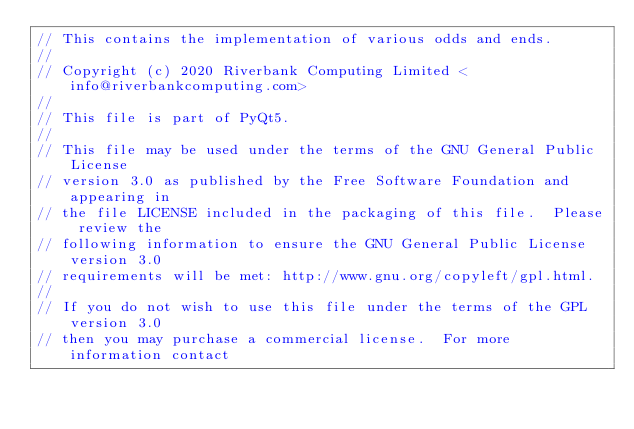Convert code to text. <code><loc_0><loc_0><loc_500><loc_500><_C++_>// This contains the implementation of various odds and ends.
//
// Copyright (c) 2020 Riverbank Computing Limited <info@riverbankcomputing.com>
// 
// This file is part of PyQt5.
// 
// This file may be used under the terms of the GNU General Public License
// version 3.0 as published by the Free Software Foundation and appearing in
// the file LICENSE included in the packaging of this file.  Please review the
// following information to ensure the GNU General Public License version 3.0
// requirements will be met: http://www.gnu.org/copyleft/gpl.html.
// 
// If you do not wish to use this file under the terms of the GPL version 3.0
// then you may purchase a commercial license.  For more information contact</code> 